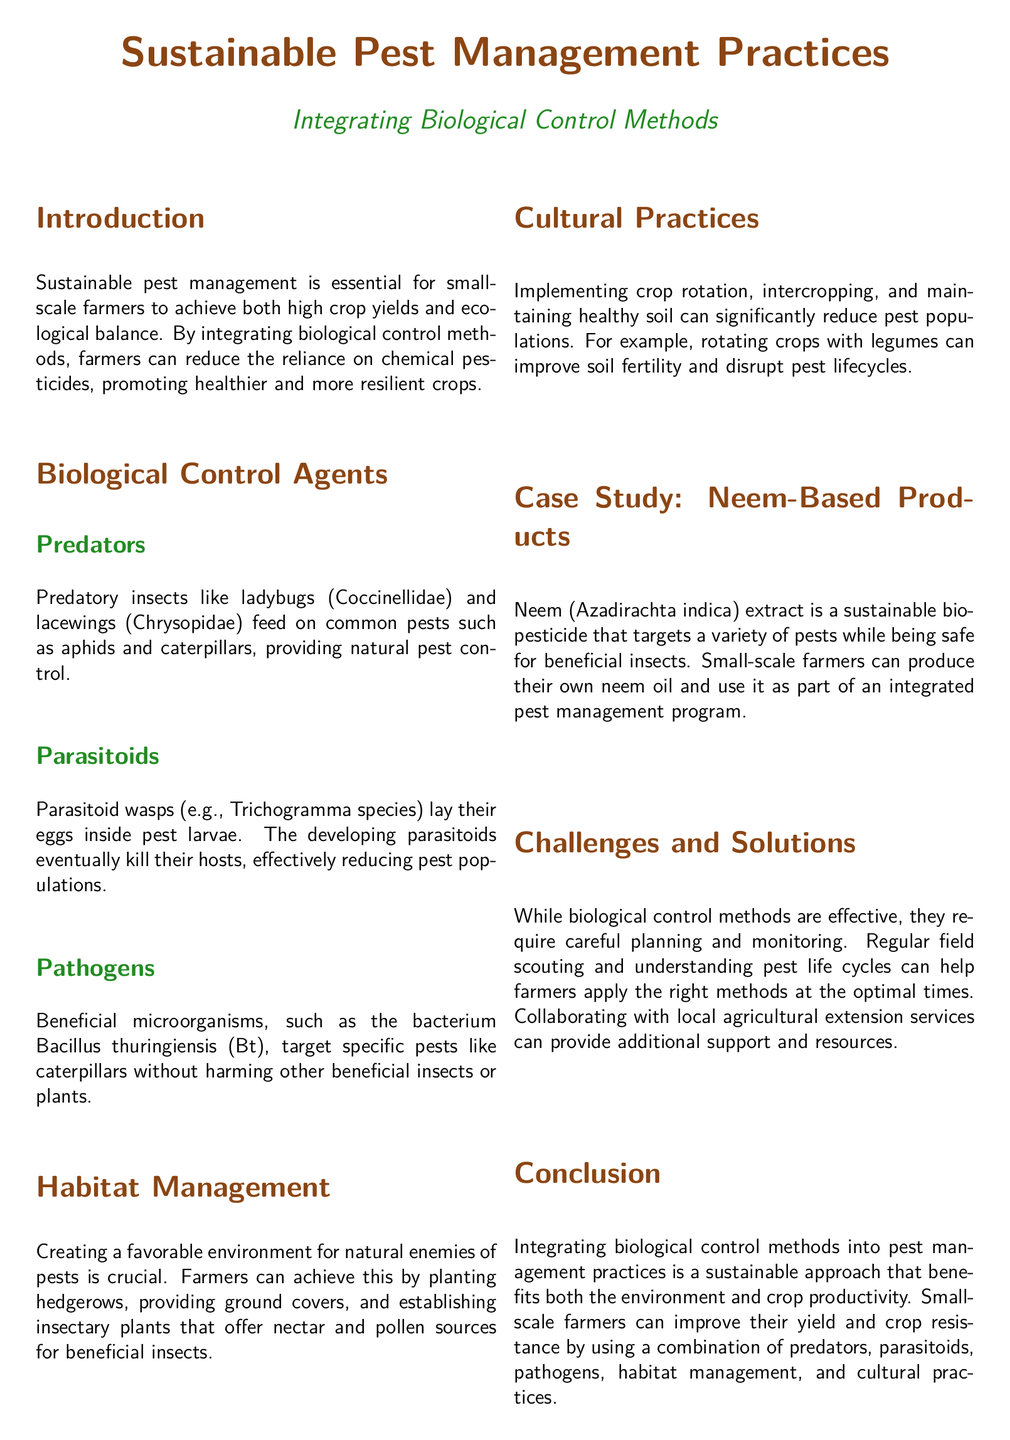What is the main topic of the document? The title of the document indicates the focus is on sustainable pest management practices through biological control methods.
Answer: Sustainable Pest Management Practices Who are the authors of the document? At the bottom of the document, it mentions the author as the Agricultural Sustainability Network.
Answer: Agricultural Sustainability Network What type of harmful insects do ladybugs control? The document states that ladybugs feed on pests such as aphids and caterpillars, which specifies the type of insects they control.
Answer: Aphids and caterpillars What is a key benefit of using Bacillus thuringiensis? The document highlights that Bacillus thuringiensis specifically targets caterpillars without affecting beneficial insects or plants.
Answer: Target specific pests What are two cultural practices mentioned that can reduce pest populations? The document lists crop rotation and intercropping as cultural practices that can help in managing pest populations effectively.
Answer: Crop rotation and intercropping How does neem extract benefit small-scale farmers? The case study outlines that neem extract is a sustainable bio-pesticide that targets a variety of pests while being safe for beneficial insects.
Answer: Targets a variety of pests safely Which management practice supports beneficial insects? The document emphasizes habitat management as a way to create a favorable environment for natural pest predators.
Answer: Habitat Management What is one challenge of biological control methods? The document mentions that these methods require careful planning and monitoring as a main challenge.
Answer: Careful planning and monitoring 